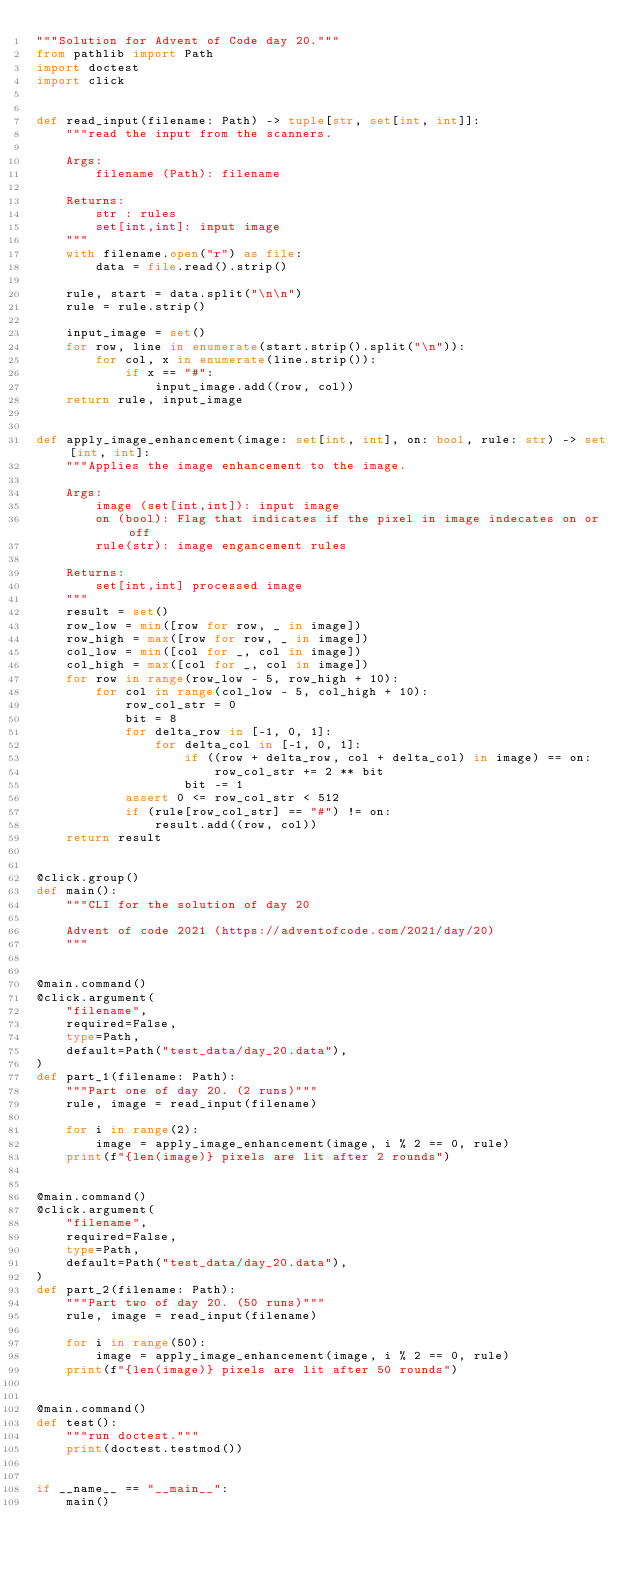Convert code to text. <code><loc_0><loc_0><loc_500><loc_500><_Python_>"""Solution for Advent of Code day 20."""
from pathlib import Path
import doctest
import click


def read_input(filename: Path) -> tuple[str, set[int, int]]:
    """read the input from the scanners.

    Args:
        filename (Path): filename

    Returns:
        str : rules
        set[int,int]: input image
    """
    with filename.open("r") as file:
        data = file.read().strip()

    rule, start = data.split("\n\n")
    rule = rule.strip()

    input_image = set()
    for row, line in enumerate(start.strip().split("\n")):
        for col, x in enumerate(line.strip()):
            if x == "#":
                input_image.add((row, col))
    return rule, input_image


def apply_image_enhancement(image: set[int, int], on: bool, rule: str) -> set[int, int]:
    """Applies the image enhancement to the image.

    Args:
        image (set[int,int]): input image
        on (bool): Flag that indicates if the pixel in image indecates on or off
        rule(str): image engancement rules

    Returns:
        set[int,int] processed image
    """
    result = set()
    row_low = min([row for row, _ in image])
    row_high = max([row for row, _ in image])
    col_low = min([col for _, col in image])
    col_high = max([col for _, col in image])
    for row in range(row_low - 5, row_high + 10):
        for col in range(col_low - 5, col_high + 10):
            row_col_str = 0
            bit = 8
            for delta_row in [-1, 0, 1]:
                for delta_col in [-1, 0, 1]:
                    if ((row + delta_row, col + delta_col) in image) == on:
                        row_col_str += 2 ** bit
                    bit -= 1
            assert 0 <= row_col_str < 512
            if (rule[row_col_str] == "#") != on:
                result.add((row, col))
    return result


@click.group()
def main():
    """CLI for the solution of day 20

    Advent of code 2021 (https://adventofcode.com/2021/day/20)
    """


@main.command()
@click.argument(
    "filename",
    required=False,
    type=Path,
    default=Path("test_data/day_20.data"),
)
def part_1(filename: Path):
    """Part one of day 20. (2 runs)"""
    rule, image = read_input(filename)

    for i in range(2):
        image = apply_image_enhancement(image, i % 2 == 0, rule)
    print(f"{len(image)} pixels are lit after 2 rounds")


@main.command()
@click.argument(
    "filename",
    required=False,
    type=Path,
    default=Path("test_data/day_20.data"),
)
def part_2(filename: Path):
    """Part two of day 20. (50 runs)"""
    rule, image = read_input(filename)

    for i in range(50):
        image = apply_image_enhancement(image, i % 2 == 0, rule)
    print(f"{len(image)} pixels are lit after 50 rounds")


@main.command()
def test():
    """run doctest."""
    print(doctest.testmod())


if __name__ == "__main__":
    main()
</code> 